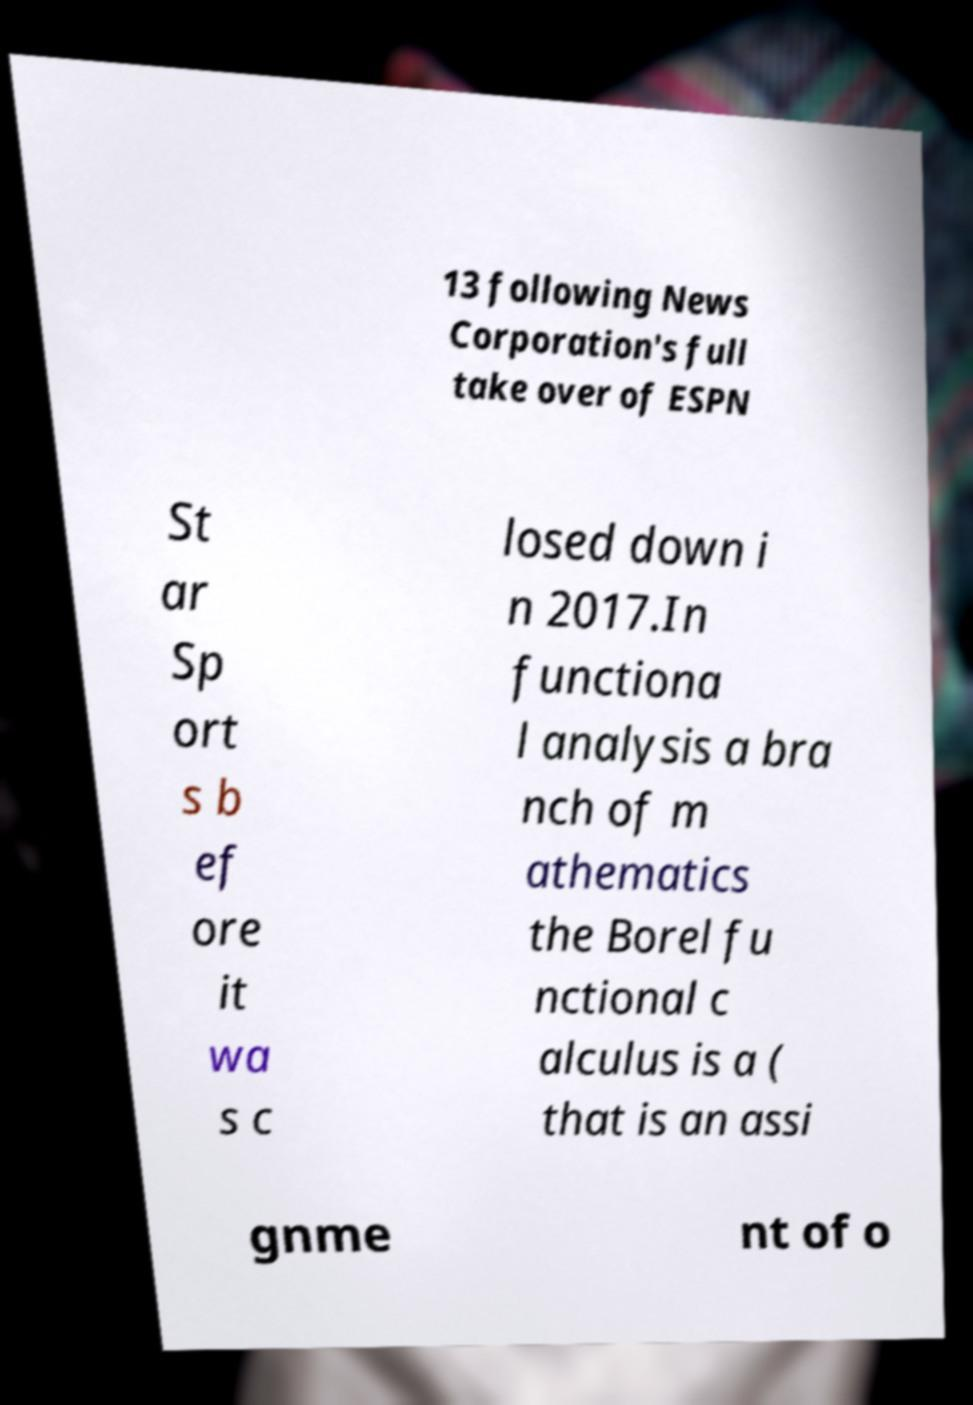For documentation purposes, I need the text within this image transcribed. Could you provide that? 13 following News Corporation's full take over of ESPN St ar Sp ort s b ef ore it wa s c losed down i n 2017.In functiona l analysis a bra nch of m athematics the Borel fu nctional c alculus is a ( that is an assi gnme nt of o 